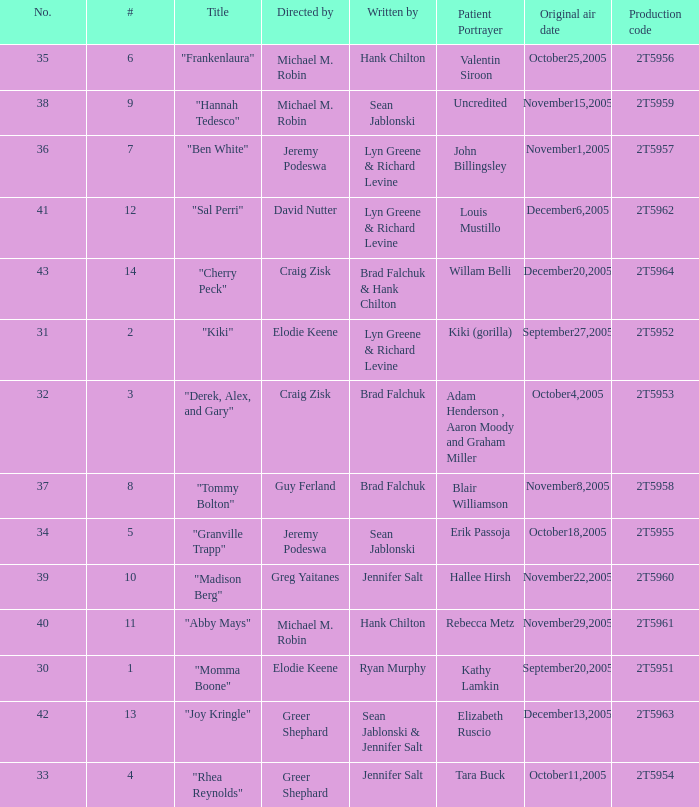What is the production code for the episode where the patient portrayer is Kathy Lamkin? 2T5951. 